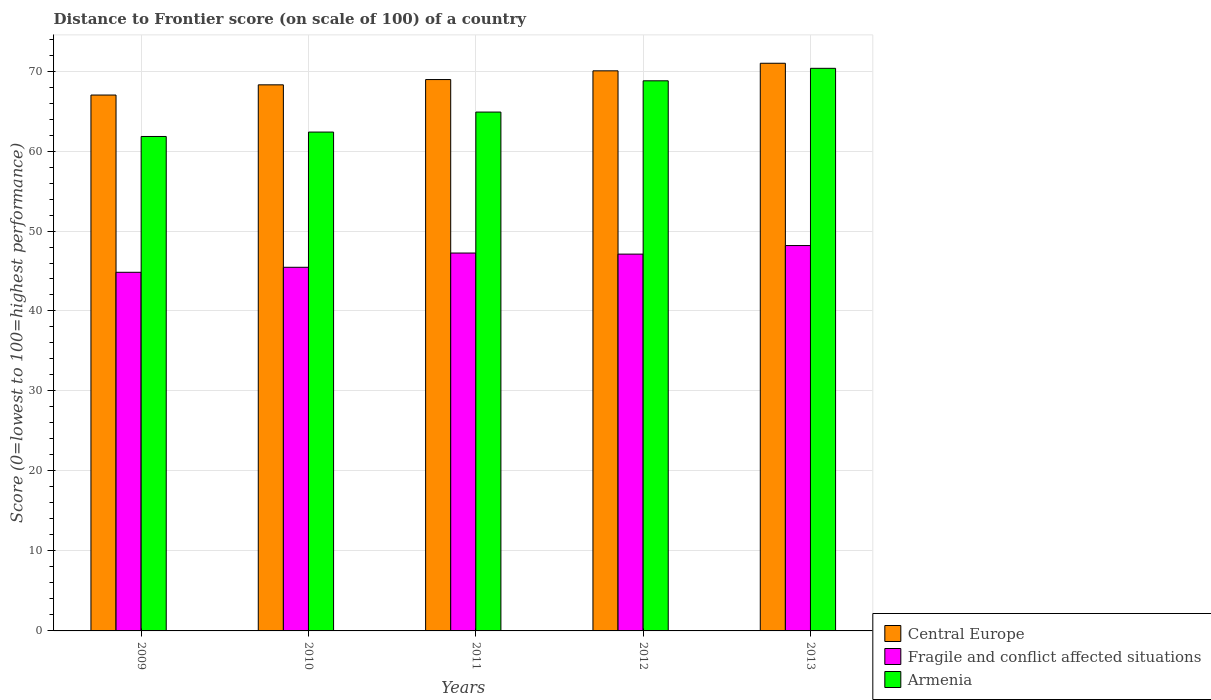How many groups of bars are there?
Offer a terse response. 5. Are the number of bars on each tick of the X-axis equal?
Your answer should be compact. Yes. How many bars are there on the 4th tick from the right?
Make the answer very short. 3. In how many cases, is the number of bars for a given year not equal to the number of legend labels?
Your response must be concise. 0. What is the distance to frontier score of in Central Europe in 2013?
Ensure brevity in your answer.  70.97. Across all years, what is the maximum distance to frontier score of in Armenia?
Keep it short and to the point. 70.34. In which year was the distance to frontier score of in Fragile and conflict affected situations maximum?
Make the answer very short. 2013. In which year was the distance to frontier score of in Armenia minimum?
Keep it short and to the point. 2009. What is the total distance to frontier score of in Central Europe in the graph?
Ensure brevity in your answer.  345.21. What is the difference between the distance to frontier score of in Fragile and conflict affected situations in 2009 and that in 2011?
Ensure brevity in your answer.  -2.41. What is the difference between the distance to frontier score of in Fragile and conflict affected situations in 2009 and the distance to frontier score of in Armenia in 2012?
Give a very brief answer. -23.94. What is the average distance to frontier score of in Fragile and conflict affected situations per year?
Give a very brief answer. 46.57. In the year 2012, what is the difference between the distance to frontier score of in Central Europe and distance to frontier score of in Fragile and conflict affected situations?
Your answer should be very brief. 22.91. In how many years, is the distance to frontier score of in Fragile and conflict affected situations greater than 10?
Your answer should be very brief. 5. What is the ratio of the distance to frontier score of in Fragile and conflict affected situations in 2010 to that in 2011?
Make the answer very short. 0.96. Is the distance to frontier score of in Central Europe in 2010 less than that in 2013?
Make the answer very short. Yes. What is the difference between the highest and the second highest distance to frontier score of in Armenia?
Provide a succinct answer. 1.56. What is the difference between the highest and the lowest distance to frontier score of in Armenia?
Your answer should be very brief. 8.52. In how many years, is the distance to frontier score of in Central Europe greater than the average distance to frontier score of in Central Europe taken over all years?
Provide a succinct answer. 2. Is the sum of the distance to frontier score of in Armenia in 2009 and 2010 greater than the maximum distance to frontier score of in Central Europe across all years?
Ensure brevity in your answer.  Yes. What does the 2nd bar from the left in 2011 represents?
Keep it short and to the point. Fragile and conflict affected situations. What does the 1st bar from the right in 2009 represents?
Provide a short and direct response. Armenia. How many bars are there?
Ensure brevity in your answer.  15. Are all the bars in the graph horizontal?
Offer a very short reply. No. What is the difference between two consecutive major ticks on the Y-axis?
Offer a very short reply. 10. Are the values on the major ticks of Y-axis written in scientific E-notation?
Ensure brevity in your answer.  No. Does the graph contain any zero values?
Give a very brief answer. No. Where does the legend appear in the graph?
Keep it short and to the point. Bottom right. How many legend labels are there?
Give a very brief answer. 3. How are the legend labels stacked?
Offer a very short reply. Vertical. What is the title of the graph?
Your answer should be very brief. Distance to Frontier score (on scale of 100) of a country. Does "Mongolia" appear as one of the legend labels in the graph?
Your answer should be very brief. No. What is the label or title of the X-axis?
Offer a very short reply. Years. What is the label or title of the Y-axis?
Offer a terse response. Score (0=lowest to 100=highest performance). What is the Score (0=lowest to 100=highest performance) in Central Europe in 2009?
Keep it short and to the point. 67. What is the Score (0=lowest to 100=highest performance) of Fragile and conflict affected situations in 2009?
Offer a very short reply. 44.84. What is the Score (0=lowest to 100=highest performance) in Armenia in 2009?
Your response must be concise. 61.82. What is the Score (0=lowest to 100=highest performance) in Central Europe in 2010?
Make the answer very short. 68.28. What is the Score (0=lowest to 100=highest performance) in Fragile and conflict affected situations in 2010?
Give a very brief answer. 45.46. What is the Score (0=lowest to 100=highest performance) in Armenia in 2010?
Provide a short and direct response. 62.37. What is the Score (0=lowest to 100=highest performance) in Central Europe in 2011?
Offer a terse response. 68.94. What is the Score (0=lowest to 100=highest performance) of Fragile and conflict affected situations in 2011?
Give a very brief answer. 47.25. What is the Score (0=lowest to 100=highest performance) of Armenia in 2011?
Your answer should be very brief. 64.87. What is the Score (0=lowest to 100=highest performance) in Central Europe in 2012?
Offer a very short reply. 70.03. What is the Score (0=lowest to 100=highest performance) in Fragile and conflict affected situations in 2012?
Your answer should be compact. 47.11. What is the Score (0=lowest to 100=highest performance) of Armenia in 2012?
Provide a succinct answer. 68.78. What is the Score (0=lowest to 100=highest performance) in Central Europe in 2013?
Ensure brevity in your answer.  70.97. What is the Score (0=lowest to 100=highest performance) in Fragile and conflict affected situations in 2013?
Your response must be concise. 48.18. What is the Score (0=lowest to 100=highest performance) of Armenia in 2013?
Provide a short and direct response. 70.34. Across all years, what is the maximum Score (0=lowest to 100=highest performance) of Central Europe?
Your response must be concise. 70.97. Across all years, what is the maximum Score (0=lowest to 100=highest performance) in Fragile and conflict affected situations?
Make the answer very short. 48.18. Across all years, what is the maximum Score (0=lowest to 100=highest performance) of Armenia?
Your answer should be compact. 70.34. Across all years, what is the minimum Score (0=lowest to 100=highest performance) of Central Europe?
Your answer should be very brief. 67. Across all years, what is the minimum Score (0=lowest to 100=highest performance) of Fragile and conflict affected situations?
Provide a succinct answer. 44.84. Across all years, what is the minimum Score (0=lowest to 100=highest performance) in Armenia?
Make the answer very short. 61.82. What is the total Score (0=lowest to 100=highest performance) of Central Europe in the graph?
Give a very brief answer. 345.21. What is the total Score (0=lowest to 100=highest performance) in Fragile and conflict affected situations in the graph?
Give a very brief answer. 232.84. What is the total Score (0=lowest to 100=highest performance) of Armenia in the graph?
Make the answer very short. 328.18. What is the difference between the Score (0=lowest to 100=highest performance) of Central Europe in 2009 and that in 2010?
Offer a very short reply. -1.28. What is the difference between the Score (0=lowest to 100=highest performance) in Fragile and conflict affected situations in 2009 and that in 2010?
Provide a short and direct response. -0.63. What is the difference between the Score (0=lowest to 100=highest performance) of Armenia in 2009 and that in 2010?
Your response must be concise. -0.55. What is the difference between the Score (0=lowest to 100=highest performance) in Central Europe in 2009 and that in 2011?
Keep it short and to the point. -1.94. What is the difference between the Score (0=lowest to 100=highest performance) in Fragile and conflict affected situations in 2009 and that in 2011?
Give a very brief answer. -2.41. What is the difference between the Score (0=lowest to 100=highest performance) in Armenia in 2009 and that in 2011?
Offer a very short reply. -3.05. What is the difference between the Score (0=lowest to 100=highest performance) of Central Europe in 2009 and that in 2012?
Offer a very short reply. -3.03. What is the difference between the Score (0=lowest to 100=highest performance) in Fragile and conflict affected situations in 2009 and that in 2012?
Keep it short and to the point. -2.27. What is the difference between the Score (0=lowest to 100=highest performance) in Armenia in 2009 and that in 2012?
Keep it short and to the point. -6.96. What is the difference between the Score (0=lowest to 100=highest performance) in Central Europe in 2009 and that in 2013?
Your response must be concise. -3.97. What is the difference between the Score (0=lowest to 100=highest performance) of Fragile and conflict affected situations in 2009 and that in 2013?
Ensure brevity in your answer.  -3.34. What is the difference between the Score (0=lowest to 100=highest performance) in Armenia in 2009 and that in 2013?
Keep it short and to the point. -8.52. What is the difference between the Score (0=lowest to 100=highest performance) in Central Europe in 2010 and that in 2011?
Provide a succinct answer. -0.66. What is the difference between the Score (0=lowest to 100=highest performance) of Fragile and conflict affected situations in 2010 and that in 2011?
Provide a short and direct response. -1.78. What is the difference between the Score (0=lowest to 100=highest performance) in Central Europe in 2010 and that in 2012?
Keep it short and to the point. -1.75. What is the difference between the Score (0=lowest to 100=highest performance) of Fragile and conflict affected situations in 2010 and that in 2012?
Provide a short and direct response. -1.65. What is the difference between the Score (0=lowest to 100=highest performance) of Armenia in 2010 and that in 2012?
Ensure brevity in your answer.  -6.41. What is the difference between the Score (0=lowest to 100=highest performance) in Central Europe in 2010 and that in 2013?
Offer a very short reply. -2.7. What is the difference between the Score (0=lowest to 100=highest performance) of Fragile and conflict affected situations in 2010 and that in 2013?
Give a very brief answer. -2.72. What is the difference between the Score (0=lowest to 100=highest performance) in Armenia in 2010 and that in 2013?
Ensure brevity in your answer.  -7.97. What is the difference between the Score (0=lowest to 100=highest performance) of Central Europe in 2011 and that in 2012?
Your answer should be very brief. -1.09. What is the difference between the Score (0=lowest to 100=highest performance) in Fragile and conflict affected situations in 2011 and that in 2012?
Offer a terse response. 0.13. What is the difference between the Score (0=lowest to 100=highest performance) of Armenia in 2011 and that in 2012?
Keep it short and to the point. -3.91. What is the difference between the Score (0=lowest to 100=highest performance) of Central Europe in 2011 and that in 2013?
Provide a short and direct response. -2.04. What is the difference between the Score (0=lowest to 100=highest performance) in Fragile and conflict affected situations in 2011 and that in 2013?
Make the answer very short. -0.94. What is the difference between the Score (0=lowest to 100=highest performance) in Armenia in 2011 and that in 2013?
Your answer should be compact. -5.47. What is the difference between the Score (0=lowest to 100=highest performance) in Central Europe in 2012 and that in 2013?
Make the answer very short. -0.95. What is the difference between the Score (0=lowest to 100=highest performance) of Fragile and conflict affected situations in 2012 and that in 2013?
Keep it short and to the point. -1.07. What is the difference between the Score (0=lowest to 100=highest performance) in Armenia in 2012 and that in 2013?
Your answer should be compact. -1.56. What is the difference between the Score (0=lowest to 100=highest performance) of Central Europe in 2009 and the Score (0=lowest to 100=highest performance) of Fragile and conflict affected situations in 2010?
Your answer should be very brief. 21.54. What is the difference between the Score (0=lowest to 100=highest performance) of Central Europe in 2009 and the Score (0=lowest to 100=highest performance) of Armenia in 2010?
Give a very brief answer. 4.63. What is the difference between the Score (0=lowest to 100=highest performance) of Fragile and conflict affected situations in 2009 and the Score (0=lowest to 100=highest performance) of Armenia in 2010?
Give a very brief answer. -17.53. What is the difference between the Score (0=lowest to 100=highest performance) in Central Europe in 2009 and the Score (0=lowest to 100=highest performance) in Fragile and conflict affected situations in 2011?
Your response must be concise. 19.75. What is the difference between the Score (0=lowest to 100=highest performance) of Central Europe in 2009 and the Score (0=lowest to 100=highest performance) of Armenia in 2011?
Ensure brevity in your answer.  2.13. What is the difference between the Score (0=lowest to 100=highest performance) in Fragile and conflict affected situations in 2009 and the Score (0=lowest to 100=highest performance) in Armenia in 2011?
Provide a short and direct response. -20.03. What is the difference between the Score (0=lowest to 100=highest performance) in Central Europe in 2009 and the Score (0=lowest to 100=highest performance) in Fragile and conflict affected situations in 2012?
Offer a very short reply. 19.89. What is the difference between the Score (0=lowest to 100=highest performance) in Central Europe in 2009 and the Score (0=lowest to 100=highest performance) in Armenia in 2012?
Your answer should be very brief. -1.78. What is the difference between the Score (0=lowest to 100=highest performance) in Fragile and conflict affected situations in 2009 and the Score (0=lowest to 100=highest performance) in Armenia in 2012?
Your answer should be compact. -23.94. What is the difference between the Score (0=lowest to 100=highest performance) in Central Europe in 2009 and the Score (0=lowest to 100=highest performance) in Fragile and conflict affected situations in 2013?
Keep it short and to the point. 18.82. What is the difference between the Score (0=lowest to 100=highest performance) in Central Europe in 2009 and the Score (0=lowest to 100=highest performance) in Armenia in 2013?
Offer a terse response. -3.34. What is the difference between the Score (0=lowest to 100=highest performance) in Fragile and conflict affected situations in 2009 and the Score (0=lowest to 100=highest performance) in Armenia in 2013?
Make the answer very short. -25.5. What is the difference between the Score (0=lowest to 100=highest performance) in Central Europe in 2010 and the Score (0=lowest to 100=highest performance) in Fragile and conflict affected situations in 2011?
Offer a very short reply. 21.03. What is the difference between the Score (0=lowest to 100=highest performance) of Central Europe in 2010 and the Score (0=lowest to 100=highest performance) of Armenia in 2011?
Offer a very short reply. 3.41. What is the difference between the Score (0=lowest to 100=highest performance) in Fragile and conflict affected situations in 2010 and the Score (0=lowest to 100=highest performance) in Armenia in 2011?
Offer a terse response. -19.41. What is the difference between the Score (0=lowest to 100=highest performance) in Central Europe in 2010 and the Score (0=lowest to 100=highest performance) in Fragile and conflict affected situations in 2012?
Provide a short and direct response. 21.16. What is the difference between the Score (0=lowest to 100=highest performance) of Central Europe in 2010 and the Score (0=lowest to 100=highest performance) of Armenia in 2012?
Provide a short and direct response. -0.5. What is the difference between the Score (0=lowest to 100=highest performance) of Fragile and conflict affected situations in 2010 and the Score (0=lowest to 100=highest performance) of Armenia in 2012?
Give a very brief answer. -23.32. What is the difference between the Score (0=lowest to 100=highest performance) in Central Europe in 2010 and the Score (0=lowest to 100=highest performance) in Fragile and conflict affected situations in 2013?
Your answer should be compact. 20.09. What is the difference between the Score (0=lowest to 100=highest performance) of Central Europe in 2010 and the Score (0=lowest to 100=highest performance) of Armenia in 2013?
Offer a very short reply. -2.06. What is the difference between the Score (0=lowest to 100=highest performance) in Fragile and conflict affected situations in 2010 and the Score (0=lowest to 100=highest performance) in Armenia in 2013?
Provide a succinct answer. -24.88. What is the difference between the Score (0=lowest to 100=highest performance) in Central Europe in 2011 and the Score (0=lowest to 100=highest performance) in Fragile and conflict affected situations in 2012?
Provide a succinct answer. 21.82. What is the difference between the Score (0=lowest to 100=highest performance) in Central Europe in 2011 and the Score (0=lowest to 100=highest performance) in Armenia in 2012?
Ensure brevity in your answer.  0.16. What is the difference between the Score (0=lowest to 100=highest performance) of Fragile and conflict affected situations in 2011 and the Score (0=lowest to 100=highest performance) of Armenia in 2012?
Your answer should be compact. -21.53. What is the difference between the Score (0=lowest to 100=highest performance) in Central Europe in 2011 and the Score (0=lowest to 100=highest performance) in Fragile and conflict affected situations in 2013?
Keep it short and to the point. 20.75. What is the difference between the Score (0=lowest to 100=highest performance) in Central Europe in 2011 and the Score (0=lowest to 100=highest performance) in Armenia in 2013?
Keep it short and to the point. -1.4. What is the difference between the Score (0=lowest to 100=highest performance) in Fragile and conflict affected situations in 2011 and the Score (0=lowest to 100=highest performance) in Armenia in 2013?
Provide a succinct answer. -23.09. What is the difference between the Score (0=lowest to 100=highest performance) of Central Europe in 2012 and the Score (0=lowest to 100=highest performance) of Fragile and conflict affected situations in 2013?
Give a very brief answer. 21.84. What is the difference between the Score (0=lowest to 100=highest performance) of Central Europe in 2012 and the Score (0=lowest to 100=highest performance) of Armenia in 2013?
Offer a very short reply. -0.31. What is the difference between the Score (0=lowest to 100=highest performance) of Fragile and conflict affected situations in 2012 and the Score (0=lowest to 100=highest performance) of Armenia in 2013?
Ensure brevity in your answer.  -23.23. What is the average Score (0=lowest to 100=highest performance) in Central Europe per year?
Make the answer very short. 69.04. What is the average Score (0=lowest to 100=highest performance) of Fragile and conflict affected situations per year?
Provide a short and direct response. 46.57. What is the average Score (0=lowest to 100=highest performance) in Armenia per year?
Ensure brevity in your answer.  65.64. In the year 2009, what is the difference between the Score (0=lowest to 100=highest performance) of Central Europe and Score (0=lowest to 100=highest performance) of Fragile and conflict affected situations?
Your answer should be compact. 22.16. In the year 2009, what is the difference between the Score (0=lowest to 100=highest performance) of Central Europe and Score (0=lowest to 100=highest performance) of Armenia?
Make the answer very short. 5.18. In the year 2009, what is the difference between the Score (0=lowest to 100=highest performance) of Fragile and conflict affected situations and Score (0=lowest to 100=highest performance) of Armenia?
Offer a terse response. -16.98. In the year 2010, what is the difference between the Score (0=lowest to 100=highest performance) of Central Europe and Score (0=lowest to 100=highest performance) of Fragile and conflict affected situations?
Offer a very short reply. 22.81. In the year 2010, what is the difference between the Score (0=lowest to 100=highest performance) in Central Europe and Score (0=lowest to 100=highest performance) in Armenia?
Provide a succinct answer. 5.91. In the year 2010, what is the difference between the Score (0=lowest to 100=highest performance) in Fragile and conflict affected situations and Score (0=lowest to 100=highest performance) in Armenia?
Your answer should be compact. -16.91. In the year 2011, what is the difference between the Score (0=lowest to 100=highest performance) of Central Europe and Score (0=lowest to 100=highest performance) of Fragile and conflict affected situations?
Offer a terse response. 21.69. In the year 2011, what is the difference between the Score (0=lowest to 100=highest performance) of Central Europe and Score (0=lowest to 100=highest performance) of Armenia?
Your response must be concise. 4.07. In the year 2011, what is the difference between the Score (0=lowest to 100=highest performance) in Fragile and conflict affected situations and Score (0=lowest to 100=highest performance) in Armenia?
Your response must be concise. -17.62. In the year 2012, what is the difference between the Score (0=lowest to 100=highest performance) of Central Europe and Score (0=lowest to 100=highest performance) of Fragile and conflict affected situations?
Your response must be concise. 22.91. In the year 2012, what is the difference between the Score (0=lowest to 100=highest performance) of Central Europe and Score (0=lowest to 100=highest performance) of Armenia?
Offer a terse response. 1.25. In the year 2012, what is the difference between the Score (0=lowest to 100=highest performance) of Fragile and conflict affected situations and Score (0=lowest to 100=highest performance) of Armenia?
Provide a succinct answer. -21.67. In the year 2013, what is the difference between the Score (0=lowest to 100=highest performance) of Central Europe and Score (0=lowest to 100=highest performance) of Fragile and conflict affected situations?
Your response must be concise. 22.79. In the year 2013, what is the difference between the Score (0=lowest to 100=highest performance) of Central Europe and Score (0=lowest to 100=highest performance) of Armenia?
Provide a succinct answer. 0.63. In the year 2013, what is the difference between the Score (0=lowest to 100=highest performance) in Fragile and conflict affected situations and Score (0=lowest to 100=highest performance) in Armenia?
Make the answer very short. -22.16. What is the ratio of the Score (0=lowest to 100=highest performance) in Central Europe in 2009 to that in 2010?
Your answer should be compact. 0.98. What is the ratio of the Score (0=lowest to 100=highest performance) in Fragile and conflict affected situations in 2009 to that in 2010?
Ensure brevity in your answer.  0.99. What is the ratio of the Score (0=lowest to 100=highest performance) in Central Europe in 2009 to that in 2011?
Provide a short and direct response. 0.97. What is the ratio of the Score (0=lowest to 100=highest performance) in Fragile and conflict affected situations in 2009 to that in 2011?
Provide a short and direct response. 0.95. What is the ratio of the Score (0=lowest to 100=highest performance) of Armenia in 2009 to that in 2011?
Provide a succinct answer. 0.95. What is the ratio of the Score (0=lowest to 100=highest performance) in Central Europe in 2009 to that in 2012?
Offer a very short reply. 0.96. What is the ratio of the Score (0=lowest to 100=highest performance) in Fragile and conflict affected situations in 2009 to that in 2012?
Ensure brevity in your answer.  0.95. What is the ratio of the Score (0=lowest to 100=highest performance) of Armenia in 2009 to that in 2012?
Offer a terse response. 0.9. What is the ratio of the Score (0=lowest to 100=highest performance) in Central Europe in 2009 to that in 2013?
Your response must be concise. 0.94. What is the ratio of the Score (0=lowest to 100=highest performance) of Fragile and conflict affected situations in 2009 to that in 2013?
Your response must be concise. 0.93. What is the ratio of the Score (0=lowest to 100=highest performance) of Armenia in 2009 to that in 2013?
Your answer should be compact. 0.88. What is the ratio of the Score (0=lowest to 100=highest performance) of Central Europe in 2010 to that in 2011?
Give a very brief answer. 0.99. What is the ratio of the Score (0=lowest to 100=highest performance) of Fragile and conflict affected situations in 2010 to that in 2011?
Offer a very short reply. 0.96. What is the ratio of the Score (0=lowest to 100=highest performance) of Armenia in 2010 to that in 2011?
Ensure brevity in your answer.  0.96. What is the ratio of the Score (0=lowest to 100=highest performance) of Armenia in 2010 to that in 2012?
Provide a short and direct response. 0.91. What is the ratio of the Score (0=lowest to 100=highest performance) in Fragile and conflict affected situations in 2010 to that in 2013?
Offer a terse response. 0.94. What is the ratio of the Score (0=lowest to 100=highest performance) of Armenia in 2010 to that in 2013?
Offer a terse response. 0.89. What is the ratio of the Score (0=lowest to 100=highest performance) in Central Europe in 2011 to that in 2012?
Offer a terse response. 0.98. What is the ratio of the Score (0=lowest to 100=highest performance) of Fragile and conflict affected situations in 2011 to that in 2012?
Give a very brief answer. 1. What is the ratio of the Score (0=lowest to 100=highest performance) in Armenia in 2011 to that in 2012?
Offer a terse response. 0.94. What is the ratio of the Score (0=lowest to 100=highest performance) in Central Europe in 2011 to that in 2013?
Offer a terse response. 0.97. What is the ratio of the Score (0=lowest to 100=highest performance) in Fragile and conflict affected situations in 2011 to that in 2013?
Offer a terse response. 0.98. What is the ratio of the Score (0=lowest to 100=highest performance) of Armenia in 2011 to that in 2013?
Offer a terse response. 0.92. What is the ratio of the Score (0=lowest to 100=highest performance) of Central Europe in 2012 to that in 2013?
Provide a short and direct response. 0.99. What is the ratio of the Score (0=lowest to 100=highest performance) in Fragile and conflict affected situations in 2012 to that in 2013?
Make the answer very short. 0.98. What is the ratio of the Score (0=lowest to 100=highest performance) of Armenia in 2012 to that in 2013?
Give a very brief answer. 0.98. What is the difference between the highest and the second highest Score (0=lowest to 100=highest performance) of Central Europe?
Make the answer very short. 0.95. What is the difference between the highest and the second highest Score (0=lowest to 100=highest performance) in Fragile and conflict affected situations?
Ensure brevity in your answer.  0.94. What is the difference between the highest and the second highest Score (0=lowest to 100=highest performance) in Armenia?
Keep it short and to the point. 1.56. What is the difference between the highest and the lowest Score (0=lowest to 100=highest performance) in Central Europe?
Your answer should be very brief. 3.97. What is the difference between the highest and the lowest Score (0=lowest to 100=highest performance) in Fragile and conflict affected situations?
Provide a succinct answer. 3.34. What is the difference between the highest and the lowest Score (0=lowest to 100=highest performance) in Armenia?
Offer a terse response. 8.52. 